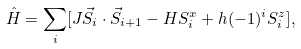<formula> <loc_0><loc_0><loc_500><loc_500>\hat { H } = \sum _ { i } [ J \vec { S } _ { i } \cdot \vec { S } _ { i + 1 } - H S ^ { x } _ { i } + h ( - 1 ) ^ { i } S ^ { z } _ { i } ] ,</formula> 